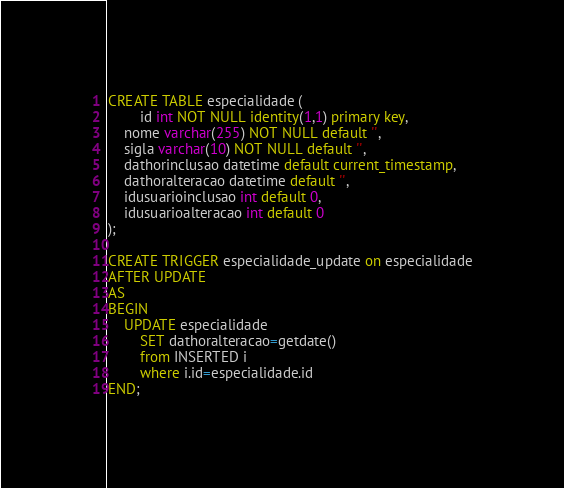<code> <loc_0><loc_0><loc_500><loc_500><_SQL_>CREATE TABLE especialidade (
        id int NOT NULL identity(1,1) primary key,
	nome varchar(255) NOT NULL default '',
	sigla varchar(10) NOT NULL default '',
	dathorinclusao datetime default current_timestamp,
	dathoralteracao datetime default '',
	idusuarioinclusao int default 0,
	idusuarioalteracao int default 0
);

CREATE TRIGGER especialidade_update on especialidade
AFTER UPDATE
AS
BEGIN
	UPDATE especialidade
        SET dathoralteracao=getdate()
        from INSERTED i
        where i.id=especialidade.id
END;
</code> 